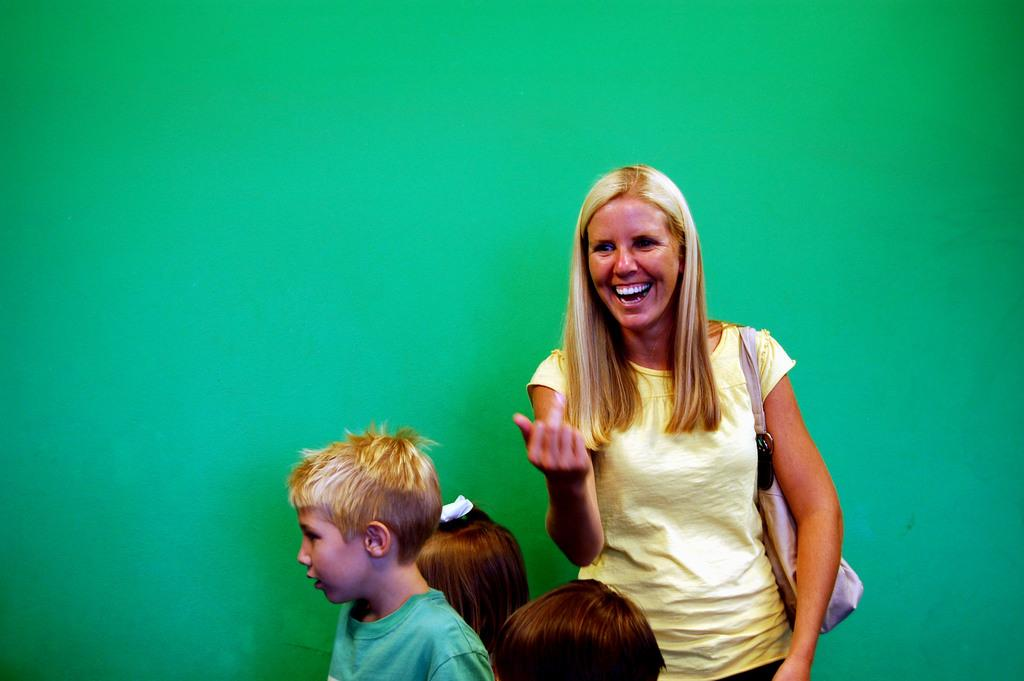Who is the main subject in the image? There is a woman in the image. What is the woman wearing? The woman is wearing a yellow dress. What is the woman doing in the image? The woman is standing and laughing. How many kids are present in the image? There are three kids beside the woman. What color is the background wall in the image? The background wall is green in color. What type of fire can be seen in the image? There is no fire present in the image. What rule is being enforced by the woman in the image? The image does not depict the woman enforcing any rules; she is standing and laughing with the kids. 